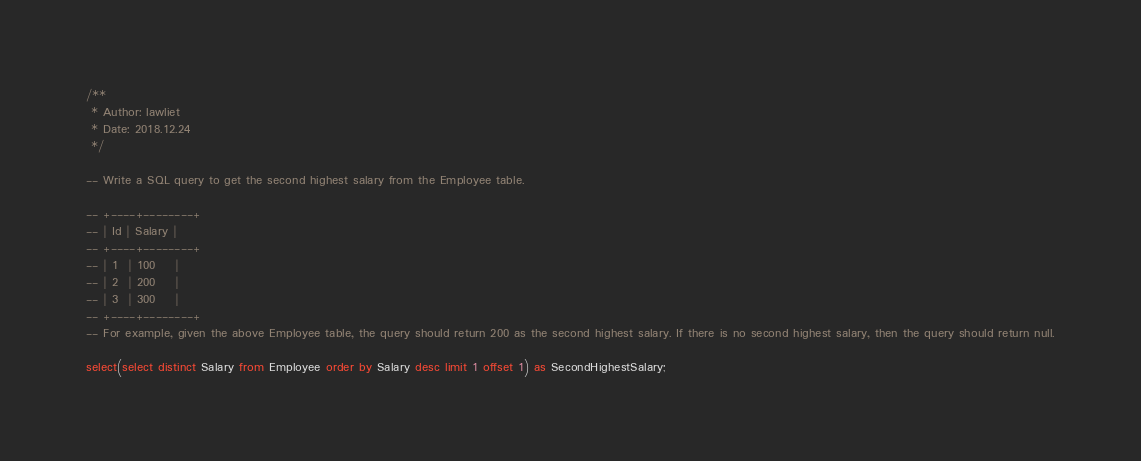Convert code to text. <code><loc_0><loc_0><loc_500><loc_500><_SQL_>/**
 * Author: lawliet
 * Date: 2018.12.24
 */ 

-- Write a SQL query to get the second highest salary from the Employee table.

-- +----+--------+
-- | Id | Salary |
-- +----+--------+
-- | 1  | 100    |
-- | 2  | 200    |
-- | 3  | 300    |
-- +----+--------+
-- For example, given the above Employee table, the query should return 200 as the second highest salary. If there is no second highest salary, then the query should return null.

select(select distinct Salary from Employee order by Salary desc limit 1 offset 1) as SecondHighestSalary;</code> 